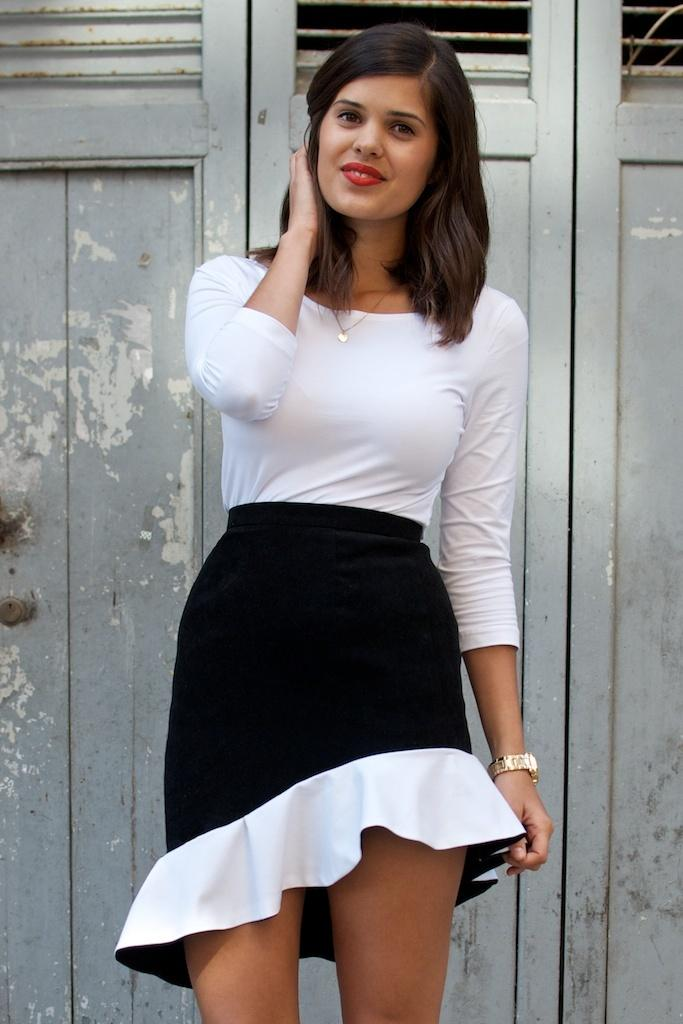Who is the main subject in the image? There is a lady in the center of the image. What is the lady doing in the image? The lady is standing and smiling. What can be seen in the background of the image? There is a door in the background of the image. What type of wilderness experience does the lady have in the image? There is no wilderness present in the image, and therefore no such experience can be observed. 